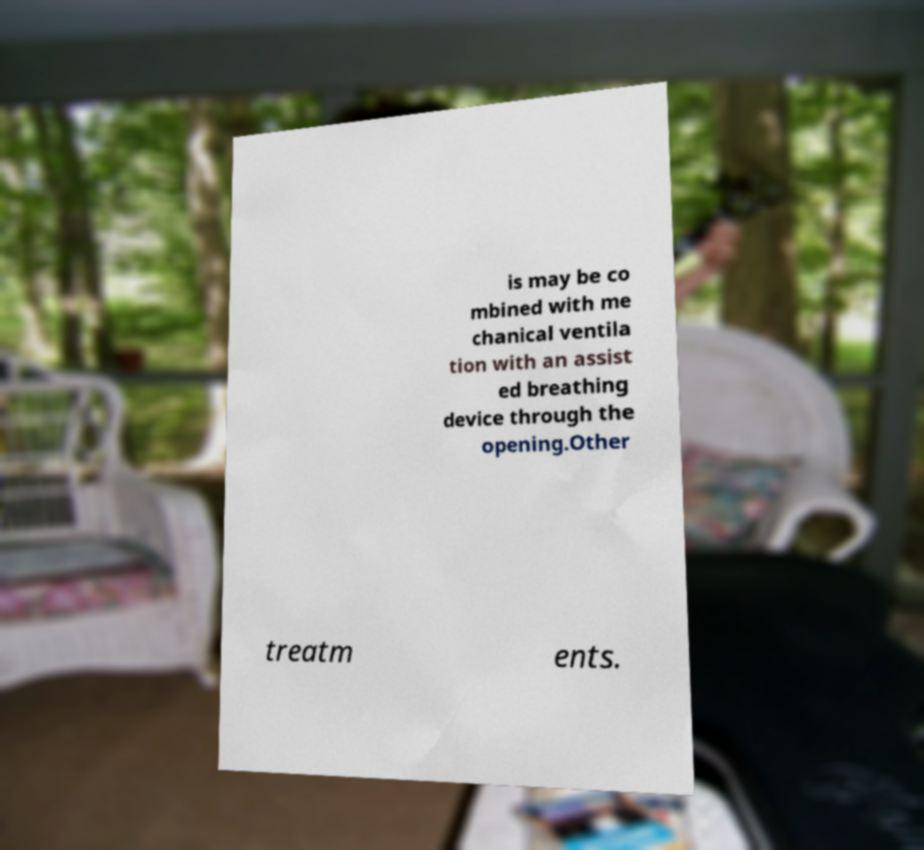There's text embedded in this image that I need extracted. Can you transcribe it verbatim? is may be co mbined with me chanical ventila tion with an assist ed breathing device through the opening.Other treatm ents. 